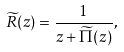<formula> <loc_0><loc_0><loc_500><loc_500>\widetilde { R } ( z ) = \frac { 1 } { z + \widetilde { \Pi } ( z ) } ,</formula> 